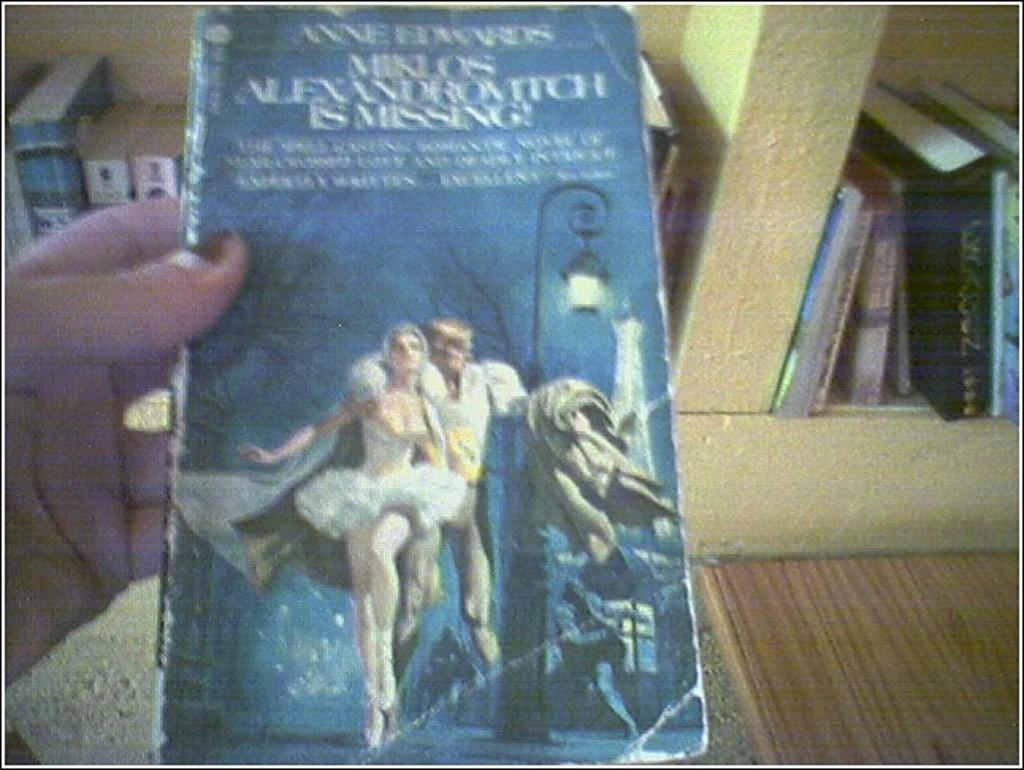<image>
Provide a brief description of the given image. A battered looking paperback was written by someone called Anne. 